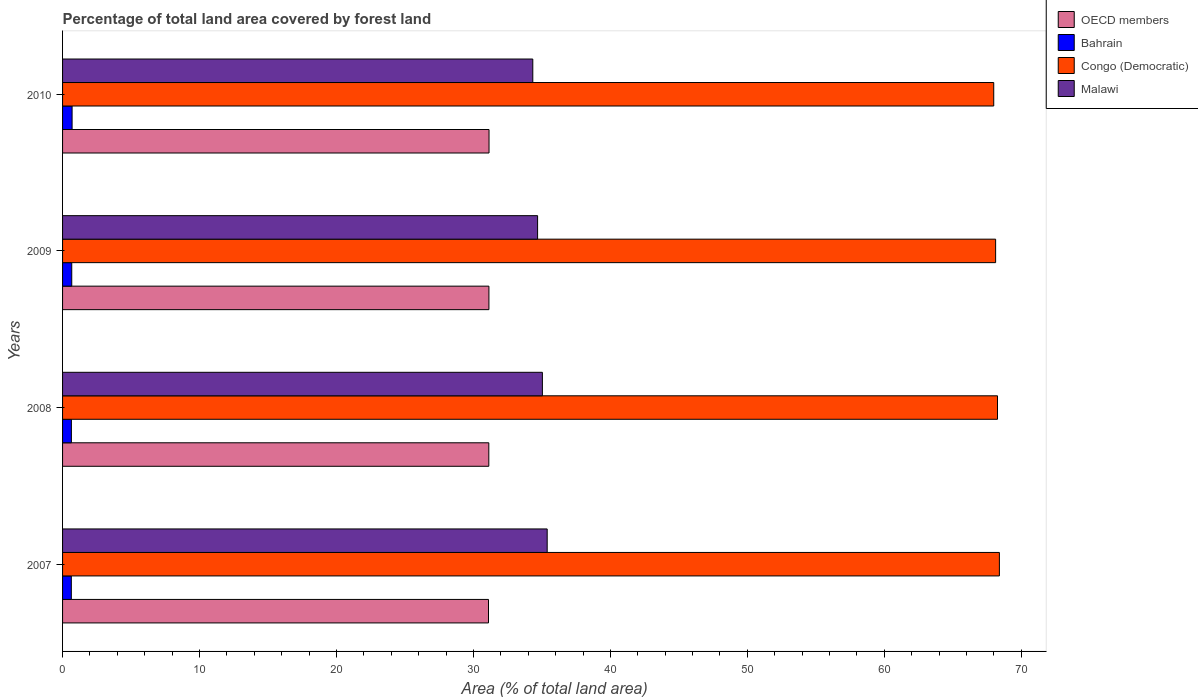How many groups of bars are there?
Your answer should be very brief. 4. In how many cases, is the number of bars for a given year not equal to the number of legend labels?
Provide a succinct answer. 0. What is the percentage of forest land in Malawi in 2008?
Provide a short and direct response. 35.03. Across all years, what is the maximum percentage of forest land in Bahrain?
Your answer should be very brief. 0.7. Across all years, what is the minimum percentage of forest land in Bahrain?
Provide a short and direct response. 0.64. In which year was the percentage of forest land in Malawi maximum?
Provide a succinct answer. 2007. In which year was the percentage of forest land in Malawi minimum?
Your answer should be very brief. 2010. What is the total percentage of forest land in OECD members in the graph?
Offer a very short reply. 124.49. What is the difference between the percentage of forest land in OECD members in 2007 and that in 2009?
Give a very brief answer. -0.03. What is the difference between the percentage of forest land in Congo (Democratic) in 2009 and the percentage of forest land in Bahrain in 2007?
Keep it short and to the point. 67.49. What is the average percentage of forest land in OECD members per year?
Give a very brief answer. 31.12. In the year 2007, what is the difference between the percentage of forest land in OECD members and percentage of forest land in Bahrain?
Provide a succinct answer. 30.46. What is the ratio of the percentage of forest land in Bahrain in 2007 to that in 2010?
Ensure brevity in your answer.  0.92. What is the difference between the highest and the second highest percentage of forest land in Congo (Democratic)?
Offer a very short reply. 0.14. What is the difference between the highest and the lowest percentage of forest land in Bahrain?
Your response must be concise. 0.06. In how many years, is the percentage of forest land in OECD members greater than the average percentage of forest land in OECD members taken over all years?
Keep it short and to the point. 2. Is it the case that in every year, the sum of the percentage of forest land in Malawi and percentage of forest land in Congo (Democratic) is greater than the sum of percentage of forest land in OECD members and percentage of forest land in Bahrain?
Provide a short and direct response. Yes. What does the 3rd bar from the top in 2009 represents?
Your answer should be compact. Bahrain. What does the 3rd bar from the bottom in 2009 represents?
Ensure brevity in your answer.  Congo (Democratic). How many bars are there?
Make the answer very short. 16. What is the difference between two consecutive major ticks on the X-axis?
Your response must be concise. 10. Does the graph contain any zero values?
Make the answer very short. No. How many legend labels are there?
Make the answer very short. 4. What is the title of the graph?
Ensure brevity in your answer.  Percentage of total land area covered by forest land. What is the label or title of the X-axis?
Your answer should be very brief. Area (% of total land area). What is the label or title of the Y-axis?
Ensure brevity in your answer.  Years. What is the Area (% of total land area) of OECD members in 2007?
Offer a very short reply. 31.1. What is the Area (% of total land area) in Bahrain in 2007?
Provide a succinct answer. 0.64. What is the Area (% of total land area) in Congo (Democratic) in 2007?
Keep it short and to the point. 68.4. What is the Area (% of total land area) in Malawi in 2007?
Provide a succinct answer. 35.38. What is the Area (% of total land area) in OECD members in 2008?
Offer a very short reply. 31.12. What is the Area (% of total land area) in Bahrain in 2008?
Your answer should be compact. 0.64. What is the Area (% of total land area) in Congo (Democratic) in 2008?
Your answer should be very brief. 68.26. What is the Area (% of total land area) of Malawi in 2008?
Offer a terse response. 35.03. What is the Area (% of total land area) in OECD members in 2009?
Offer a terse response. 31.13. What is the Area (% of total land area) in Bahrain in 2009?
Keep it short and to the point. 0.67. What is the Area (% of total land area) of Congo (Democratic) in 2009?
Your answer should be very brief. 68.13. What is the Area (% of total land area) in Malawi in 2009?
Offer a terse response. 34.68. What is the Area (% of total land area) in OECD members in 2010?
Keep it short and to the point. 31.14. What is the Area (% of total land area) of Bahrain in 2010?
Make the answer very short. 0.7. What is the Area (% of total land area) of Congo (Democratic) in 2010?
Provide a succinct answer. 67.99. What is the Area (% of total land area) of Malawi in 2010?
Your answer should be compact. 34.33. Across all years, what is the maximum Area (% of total land area) in OECD members?
Offer a very short reply. 31.14. Across all years, what is the maximum Area (% of total land area) of Bahrain?
Keep it short and to the point. 0.7. Across all years, what is the maximum Area (% of total land area) of Congo (Democratic)?
Give a very brief answer. 68.4. Across all years, what is the maximum Area (% of total land area) of Malawi?
Your response must be concise. 35.38. Across all years, what is the minimum Area (% of total land area) in OECD members?
Provide a succinct answer. 31.1. Across all years, what is the minimum Area (% of total land area) of Bahrain?
Keep it short and to the point. 0.64. Across all years, what is the minimum Area (% of total land area) of Congo (Democratic)?
Offer a terse response. 67.99. Across all years, what is the minimum Area (% of total land area) in Malawi?
Make the answer very short. 34.33. What is the total Area (% of total land area) of OECD members in the graph?
Offer a terse response. 124.49. What is the total Area (% of total land area) in Bahrain in the graph?
Make the answer very short. 2.65. What is the total Area (% of total land area) in Congo (Democratic) in the graph?
Make the answer very short. 272.78. What is the total Area (% of total land area) in Malawi in the graph?
Provide a succinct answer. 139.44. What is the difference between the Area (% of total land area) in OECD members in 2007 and that in 2008?
Give a very brief answer. -0.02. What is the difference between the Area (% of total land area) in Bahrain in 2007 and that in 2008?
Keep it short and to the point. -0. What is the difference between the Area (% of total land area) of Congo (Democratic) in 2007 and that in 2008?
Your answer should be compact. 0.14. What is the difference between the Area (% of total land area) in OECD members in 2007 and that in 2009?
Provide a succinct answer. -0.03. What is the difference between the Area (% of total land area) of Bahrain in 2007 and that in 2009?
Your answer should be compact. -0.03. What is the difference between the Area (% of total land area) in Congo (Democratic) in 2007 and that in 2009?
Make the answer very short. 0.27. What is the difference between the Area (% of total land area) in Malawi in 2007 and that in 2009?
Make the answer very short. 0.7. What is the difference between the Area (% of total land area) in OECD members in 2007 and that in 2010?
Your response must be concise. -0.04. What is the difference between the Area (% of total land area) of Bahrain in 2007 and that in 2010?
Make the answer very short. -0.06. What is the difference between the Area (% of total land area) in Congo (Democratic) in 2007 and that in 2010?
Ensure brevity in your answer.  0.41. What is the difference between the Area (% of total land area) of Malawi in 2007 and that in 2010?
Offer a very short reply. 1.05. What is the difference between the Area (% of total land area) in OECD members in 2008 and that in 2009?
Provide a short and direct response. -0.01. What is the difference between the Area (% of total land area) of Bahrain in 2008 and that in 2009?
Give a very brief answer. -0.03. What is the difference between the Area (% of total land area) in Congo (Democratic) in 2008 and that in 2009?
Your answer should be very brief. 0.14. What is the difference between the Area (% of total land area) of OECD members in 2008 and that in 2010?
Keep it short and to the point. -0.02. What is the difference between the Area (% of total land area) of Bahrain in 2008 and that in 2010?
Give a very brief answer. -0.05. What is the difference between the Area (% of total land area) in Congo (Democratic) in 2008 and that in 2010?
Make the answer very short. 0.27. What is the difference between the Area (% of total land area) of Malawi in 2008 and that in 2010?
Your answer should be very brief. 0.7. What is the difference between the Area (% of total land area) of OECD members in 2009 and that in 2010?
Keep it short and to the point. -0.01. What is the difference between the Area (% of total land area) in Bahrain in 2009 and that in 2010?
Your answer should be compact. -0.02. What is the difference between the Area (% of total land area) in Congo (Democratic) in 2009 and that in 2010?
Ensure brevity in your answer.  0.14. What is the difference between the Area (% of total land area) of OECD members in 2007 and the Area (% of total land area) of Bahrain in 2008?
Your response must be concise. 30.45. What is the difference between the Area (% of total land area) of OECD members in 2007 and the Area (% of total land area) of Congo (Democratic) in 2008?
Your answer should be very brief. -37.16. What is the difference between the Area (% of total land area) of OECD members in 2007 and the Area (% of total land area) of Malawi in 2008?
Make the answer very short. -3.93. What is the difference between the Area (% of total land area) of Bahrain in 2007 and the Area (% of total land area) of Congo (Democratic) in 2008?
Ensure brevity in your answer.  -67.62. What is the difference between the Area (% of total land area) of Bahrain in 2007 and the Area (% of total land area) of Malawi in 2008?
Provide a short and direct response. -34.39. What is the difference between the Area (% of total land area) in Congo (Democratic) in 2007 and the Area (% of total land area) in Malawi in 2008?
Your answer should be very brief. 33.37. What is the difference between the Area (% of total land area) of OECD members in 2007 and the Area (% of total land area) of Bahrain in 2009?
Provide a succinct answer. 30.43. What is the difference between the Area (% of total land area) in OECD members in 2007 and the Area (% of total land area) in Congo (Democratic) in 2009?
Give a very brief answer. -37.03. What is the difference between the Area (% of total land area) of OECD members in 2007 and the Area (% of total land area) of Malawi in 2009?
Give a very brief answer. -3.58. What is the difference between the Area (% of total land area) in Bahrain in 2007 and the Area (% of total land area) in Congo (Democratic) in 2009?
Give a very brief answer. -67.49. What is the difference between the Area (% of total land area) of Bahrain in 2007 and the Area (% of total land area) of Malawi in 2009?
Your answer should be compact. -34.04. What is the difference between the Area (% of total land area) of Congo (Democratic) in 2007 and the Area (% of total land area) of Malawi in 2009?
Provide a short and direct response. 33.72. What is the difference between the Area (% of total land area) of OECD members in 2007 and the Area (% of total land area) of Bahrain in 2010?
Offer a terse response. 30.4. What is the difference between the Area (% of total land area) of OECD members in 2007 and the Area (% of total land area) of Congo (Democratic) in 2010?
Make the answer very short. -36.89. What is the difference between the Area (% of total land area) in OECD members in 2007 and the Area (% of total land area) in Malawi in 2010?
Keep it short and to the point. -3.23. What is the difference between the Area (% of total land area) of Bahrain in 2007 and the Area (% of total land area) of Congo (Democratic) in 2010?
Provide a succinct answer. -67.35. What is the difference between the Area (% of total land area) in Bahrain in 2007 and the Area (% of total land area) in Malawi in 2010?
Your answer should be very brief. -33.69. What is the difference between the Area (% of total land area) of Congo (Democratic) in 2007 and the Area (% of total land area) of Malawi in 2010?
Offer a terse response. 34.07. What is the difference between the Area (% of total land area) in OECD members in 2008 and the Area (% of total land area) in Bahrain in 2009?
Ensure brevity in your answer.  30.45. What is the difference between the Area (% of total land area) of OECD members in 2008 and the Area (% of total land area) of Congo (Democratic) in 2009?
Make the answer very short. -37. What is the difference between the Area (% of total land area) in OECD members in 2008 and the Area (% of total land area) in Malawi in 2009?
Keep it short and to the point. -3.56. What is the difference between the Area (% of total land area) in Bahrain in 2008 and the Area (% of total land area) in Congo (Democratic) in 2009?
Give a very brief answer. -67.48. What is the difference between the Area (% of total land area) of Bahrain in 2008 and the Area (% of total land area) of Malawi in 2009?
Keep it short and to the point. -34.04. What is the difference between the Area (% of total land area) in Congo (Democratic) in 2008 and the Area (% of total land area) in Malawi in 2009?
Your response must be concise. 33.58. What is the difference between the Area (% of total land area) in OECD members in 2008 and the Area (% of total land area) in Bahrain in 2010?
Provide a short and direct response. 30.43. What is the difference between the Area (% of total land area) of OECD members in 2008 and the Area (% of total land area) of Congo (Democratic) in 2010?
Provide a short and direct response. -36.87. What is the difference between the Area (% of total land area) of OECD members in 2008 and the Area (% of total land area) of Malawi in 2010?
Provide a succinct answer. -3.21. What is the difference between the Area (% of total land area) in Bahrain in 2008 and the Area (% of total land area) in Congo (Democratic) in 2010?
Offer a very short reply. -67.34. What is the difference between the Area (% of total land area) of Bahrain in 2008 and the Area (% of total land area) of Malawi in 2010?
Provide a succinct answer. -33.69. What is the difference between the Area (% of total land area) in Congo (Democratic) in 2008 and the Area (% of total land area) in Malawi in 2010?
Offer a very short reply. 33.93. What is the difference between the Area (% of total land area) in OECD members in 2009 and the Area (% of total land area) in Bahrain in 2010?
Provide a succinct answer. 30.43. What is the difference between the Area (% of total land area) in OECD members in 2009 and the Area (% of total land area) in Congo (Democratic) in 2010?
Make the answer very short. -36.86. What is the difference between the Area (% of total land area) of OECD members in 2009 and the Area (% of total land area) of Malawi in 2010?
Give a very brief answer. -3.2. What is the difference between the Area (% of total land area) in Bahrain in 2009 and the Area (% of total land area) in Congo (Democratic) in 2010?
Your response must be concise. -67.32. What is the difference between the Area (% of total land area) in Bahrain in 2009 and the Area (% of total land area) in Malawi in 2010?
Your response must be concise. -33.66. What is the difference between the Area (% of total land area) in Congo (Democratic) in 2009 and the Area (% of total land area) in Malawi in 2010?
Offer a very short reply. 33.79. What is the average Area (% of total land area) of OECD members per year?
Ensure brevity in your answer.  31.12. What is the average Area (% of total land area) of Bahrain per year?
Make the answer very short. 0.66. What is the average Area (% of total land area) in Congo (Democratic) per year?
Offer a terse response. 68.2. What is the average Area (% of total land area) of Malawi per year?
Provide a succinct answer. 34.86. In the year 2007, what is the difference between the Area (% of total land area) of OECD members and Area (% of total land area) of Bahrain?
Keep it short and to the point. 30.46. In the year 2007, what is the difference between the Area (% of total land area) in OECD members and Area (% of total land area) in Congo (Democratic)?
Provide a succinct answer. -37.3. In the year 2007, what is the difference between the Area (% of total land area) of OECD members and Area (% of total land area) of Malawi?
Ensure brevity in your answer.  -4.28. In the year 2007, what is the difference between the Area (% of total land area) of Bahrain and Area (% of total land area) of Congo (Democratic)?
Offer a very short reply. -67.76. In the year 2007, what is the difference between the Area (% of total land area) of Bahrain and Area (% of total land area) of Malawi?
Offer a very short reply. -34.74. In the year 2007, what is the difference between the Area (% of total land area) of Congo (Democratic) and Area (% of total land area) of Malawi?
Offer a very short reply. 33.02. In the year 2008, what is the difference between the Area (% of total land area) in OECD members and Area (% of total land area) in Bahrain?
Your response must be concise. 30.48. In the year 2008, what is the difference between the Area (% of total land area) of OECD members and Area (% of total land area) of Congo (Democratic)?
Keep it short and to the point. -37.14. In the year 2008, what is the difference between the Area (% of total land area) of OECD members and Area (% of total land area) of Malawi?
Your response must be concise. -3.91. In the year 2008, what is the difference between the Area (% of total land area) in Bahrain and Area (% of total land area) in Congo (Democratic)?
Offer a terse response. -67.62. In the year 2008, what is the difference between the Area (% of total land area) of Bahrain and Area (% of total land area) of Malawi?
Your answer should be very brief. -34.39. In the year 2008, what is the difference between the Area (% of total land area) of Congo (Democratic) and Area (% of total land area) of Malawi?
Your answer should be very brief. 33.23. In the year 2009, what is the difference between the Area (% of total land area) in OECD members and Area (% of total land area) in Bahrain?
Ensure brevity in your answer.  30.46. In the year 2009, what is the difference between the Area (% of total land area) in OECD members and Area (% of total land area) in Congo (Democratic)?
Your answer should be very brief. -37. In the year 2009, what is the difference between the Area (% of total land area) of OECD members and Area (% of total land area) of Malawi?
Provide a succinct answer. -3.55. In the year 2009, what is the difference between the Area (% of total land area) in Bahrain and Area (% of total land area) in Congo (Democratic)?
Your answer should be compact. -67.46. In the year 2009, what is the difference between the Area (% of total land area) of Bahrain and Area (% of total land area) of Malawi?
Provide a succinct answer. -34.01. In the year 2009, what is the difference between the Area (% of total land area) in Congo (Democratic) and Area (% of total land area) in Malawi?
Make the answer very short. 33.44. In the year 2010, what is the difference between the Area (% of total land area) of OECD members and Area (% of total land area) of Bahrain?
Offer a very short reply. 30.44. In the year 2010, what is the difference between the Area (% of total land area) in OECD members and Area (% of total land area) in Congo (Democratic)?
Offer a very short reply. -36.85. In the year 2010, what is the difference between the Area (% of total land area) of OECD members and Area (% of total land area) of Malawi?
Provide a short and direct response. -3.2. In the year 2010, what is the difference between the Area (% of total land area) in Bahrain and Area (% of total land area) in Congo (Democratic)?
Ensure brevity in your answer.  -67.29. In the year 2010, what is the difference between the Area (% of total land area) in Bahrain and Area (% of total land area) in Malawi?
Make the answer very short. -33.64. In the year 2010, what is the difference between the Area (% of total land area) of Congo (Democratic) and Area (% of total land area) of Malawi?
Keep it short and to the point. 33.66. What is the ratio of the Area (% of total land area) of Malawi in 2007 to that in 2008?
Provide a short and direct response. 1.01. What is the ratio of the Area (% of total land area) in Bahrain in 2007 to that in 2009?
Keep it short and to the point. 0.95. What is the ratio of the Area (% of total land area) in Congo (Democratic) in 2007 to that in 2009?
Keep it short and to the point. 1. What is the ratio of the Area (% of total land area) in Malawi in 2007 to that in 2009?
Your response must be concise. 1.02. What is the ratio of the Area (% of total land area) of OECD members in 2007 to that in 2010?
Offer a very short reply. 1. What is the ratio of the Area (% of total land area) of Bahrain in 2007 to that in 2010?
Your response must be concise. 0.92. What is the ratio of the Area (% of total land area) in Malawi in 2007 to that in 2010?
Make the answer very short. 1.03. What is the ratio of the Area (% of total land area) of Bahrain in 2008 to that in 2009?
Give a very brief answer. 0.96. What is the ratio of the Area (% of total land area) of Bahrain in 2008 to that in 2010?
Offer a very short reply. 0.93. What is the ratio of the Area (% of total land area) of Malawi in 2008 to that in 2010?
Your answer should be compact. 1.02. What is the ratio of the Area (% of total land area) of Bahrain in 2009 to that in 2010?
Ensure brevity in your answer.  0.96. What is the ratio of the Area (% of total land area) in Malawi in 2009 to that in 2010?
Your answer should be very brief. 1.01. What is the difference between the highest and the second highest Area (% of total land area) of OECD members?
Your answer should be compact. 0.01. What is the difference between the highest and the second highest Area (% of total land area) of Bahrain?
Your answer should be very brief. 0.02. What is the difference between the highest and the second highest Area (% of total land area) of Congo (Democratic)?
Offer a terse response. 0.14. What is the difference between the highest and the lowest Area (% of total land area) of OECD members?
Provide a succinct answer. 0.04. What is the difference between the highest and the lowest Area (% of total land area) in Bahrain?
Ensure brevity in your answer.  0.06. What is the difference between the highest and the lowest Area (% of total land area) in Congo (Democratic)?
Give a very brief answer. 0.41. What is the difference between the highest and the lowest Area (% of total land area) in Malawi?
Offer a very short reply. 1.05. 